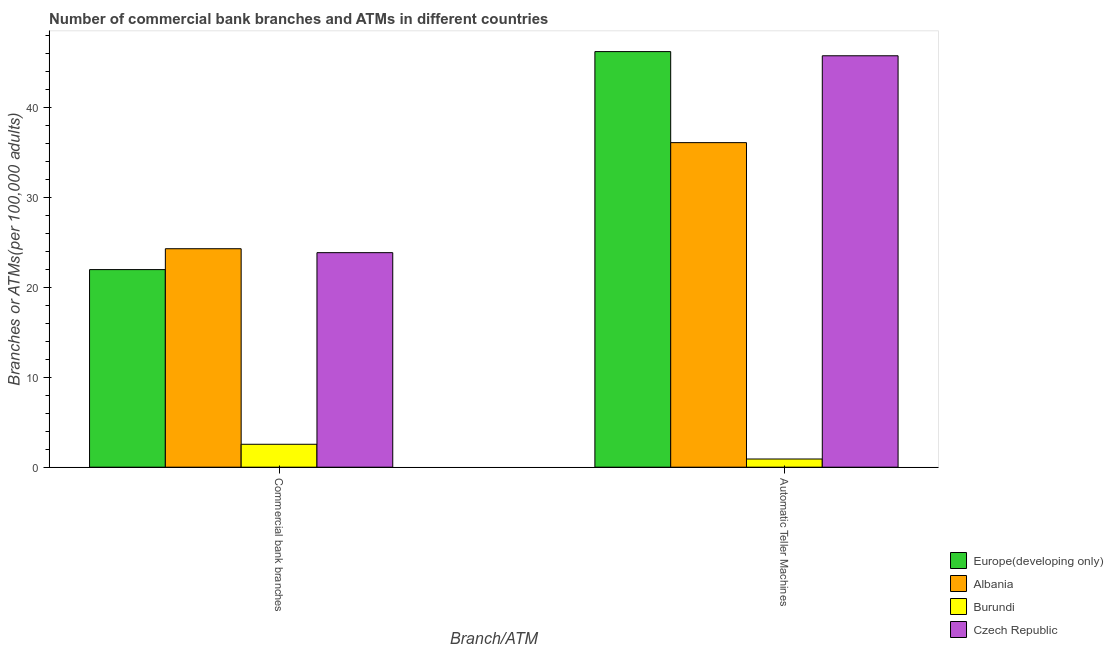How many groups of bars are there?
Your answer should be very brief. 2. Are the number of bars per tick equal to the number of legend labels?
Your answer should be very brief. Yes. How many bars are there on the 2nd tick from the right?
Offer a terse response. 4. What is the label of the 2nd group of bars from the left?
Give a very brief answer. Automatic Teller Machines. What is the number of atms in Albania?
Provide a short and direct response. 36.07. Across all countries, what is the maximum number of commercal bank branches?
Your answer should be very brief. 24.28. Across all countries, what is the minimum number of atms?
Your response must be concise. 0.91. In which country was the number of commercal bank branches maximum?
Your answer should be compact. Albania. In which country was the number of commercal bank branches minimum?
Give a very brief answer. Burundi. What is the total number of commercal bank branches in the graph?
Your answer should be very brief. 72.62. What is the difference between the number of atms in Czech Republic and that in Albania?
Your answer should be very brief. 9.65. What is the difference between the number of commercal bank branches in Burundi and the number of atms in Albania?
Offer a terse response. -33.52. What is the average number of commercal bank branches per country?
Your response must be concise. 18.16. What is the difference between the number of commercal bank branches and number of atms in Europe(developing only)?
Your response must be concise. -24.22. What is the ratio of the number of commercal bank branches in Czech Republic to that in Burundi?
Offer a very short reply. 9.36. In how many countries, is the number of atms greater than the average number of atms taken over all countries?
Offer a terse response. 3. What does the 4th bar from the left in Automatic Teller Machines represents?
Your response must be concise. Czech Republic. What does the 2nd bar from the right in Commercial bank branches represents?
Offer a very short reply. Burundi. How many bars are there?
Your response must be concise. 8. How many countries are there in the graph?
Provide a succinct answer. 4. Are the values on the major ticks of Y-axis written in scientific E-notation?
Provide a succinct answer. No. Does the graph contain any zero values?
Ensure brevity in your answer.  No. Does the graph contain grids?
Give a very brief answer. No. How many legend labels are there?
Make the answer very short. 4. How are the legend labels stacked?
Provide a short and direct response. Vertical. What is the title of the graph?
Your answer should be compact. Number of commercial bank branches and ATMs in different countries. Does "Armenia" appear as one of the legend labels in the graph?
Give a very brief answer. No. What is the label or title of the X-axis?
Keep it short and to the point. Branch/ATM. What is the label or title of the Y-axis?
Make the answer very short. Branches or ATMs(per 100,0 adults). What is the Branches or ATMs(per 100,000 adults) in Europe(developing only) in Commercial bank branches?
Offer a terse response. 21.96. What is the Branches or ATMs(per 100,000 adults) in Albania in Commercial bank branches?
Your response must be concise. 24.28. What is the Branches or ATMs(per 100,000 adults) of Burundi in Commercial bank branches?
Ensure brevity in your answer.  2.55. What is the Branches or ATMs(per 100,000 adults) of Czech Republic in Commercial bank branches?
Provide a succinct answer. 23.84. What is the Branches or ATMs(per 100,000 adults) of Europe(developing only) in Automatic Teller Machines?
Make the answer very short. 46.18. What is the Branches or ATMs(per 100,000 adults) in Albania in Automatic Teller Machines?
Provide a succinct answer. 36.07. What is the Branches or ATMs(per 100,000 adults) of Burundi in Automatic Teller Machines?
Offer a terse response. 0.91. What is the Branches or ATMs(per 100,000 adults) of Czech Republic in Automatic Teller Machines?
Your response must be concise. 45.72. Across all Branch/ATM, what is the maximum Branches or ATMs(per 100,000 adults) in Europe(developing only)?
Provide a succinct answer. 46.18. Across all Branch/ATM, what is the maximum Branches or ATMs(per 100,000 adults) in Albania?
Offer a very short reply. 36.07. Across all Branch/ATM, what is the maximum Branches or ATMs(per 100,000 adults) of Burundi?
Provide a succinct answer. 2.55. Across all Branch/ATM, what is the maximum Branches or ATMs(per 100,000 adults) in Czech Republic?
Offer a terse response. 45.72. Across all Branch/ATM, what is the minimum Branches or ATMs(per 100,000 adults) of Europe(developing only)?
Give a very brief answer. 21.96. Across all Branch/ATM, what is the minimum Branches or ATMs(per 100,000 adults) in Albania?
Your answer should be compact. 24.28. Across all Branch/ATM, what is the minimum Branches or ATMs(per 100,000 adults) in Burundi?
Ensure brevity in your answer.  0.91. Across all Branch/ATM, what is the minimum Branches or ATMs(per 100,000 adults) in Czech Republic?
Keep it short and to the point. 23.84. What is the total Branches or ATMs(per 100,000 adults) in Europe(developing only) in the graph?
Keep it short and to the point. 68.14. What is the total Branches or ATMs(per 100,000 adults) of Albania in the graph?
Ensure brevity in your answer.  60.35. What is the total Branches or ATMs(per 100,000 adults) of Burundi in the graph?
Your answer should be very brief. 3.46. What is the total Branches or ATMs(per 100,000 adults) of Czech Republic in the graph?
Give a very brief answer. 69.56. What is the difference between the Branches or ATMs(per 100,000 adults) in Europe(developing only) in Commercial bank branches and that in Automatic Teller Machines?
Ensure brevity in your answer.  -24.22. What is the difference between the Branches or ATMs(per 100,000 adults) of Albania in Commercial bank branches and that in Automatic Teller Machines?
Make the answer very short. -11.79. What is the difference between the Branches or ATMs(per 100,000 adults) in Burundi in Commercial bank branches and that in Automatic Teller Machines?
Your answer should be compact. 1.64. What is the difference between the Branches or ATMs(per 100,000 adults) of Czech Republic in Commercial bank branches and that in Automatic Teller Machines?
Your answer should be very brief. -21.88. What is the difference between the Branches or ATMs(per 100,000 adults) in Europe(developing only) in Commercial bank branches and the Branches or ATMs(per 100,000 adults) in Albania in Automatic Teller Machines?
Your answer should be very brief. -14.11. What is the difference between the Branches or ATMs(per 100,000 adults) in Europe(developing only) in Commercial bank branches and the Branches or ATMs(per 100,000 adults) in Burundi in Automatic Teller Machines?
Ensure brevity in your answer.  21.05. What is the difference between the Branches or ATMs(per 100,000 adults) in Europe(developing only) in Commercial bank branches and the Branches or ATMs(per 100,000 adults) in Czech Republic in Automatic Teller Machines?
Make the answer very short. -23.76. What is the difference between the Branches or ATMs(per 100,000 adults) in Albania in Commercial bank branches and the Branches or ATMs(per 100,000 adults) in Burundi in Automatic Teller Machines?
Ensure brevity in your answer.  23.37. What is the difference between the Branches or ATMs(per 100,000 adults) in Albania in Commercial bank branches and the Branches or ATMs(per 100,000 adults) in Czech Republic in Automatic Teller Machines?
Provide a short and direct response. -21.44. What is the difference between the Branches or ATMs(per 100,000 adults) in Burundi in Commercial bank branches and the Branches or ATMs(per 100,000 adults) in Czech Republic in Automatic Teller Machines?
Your answer should be compact. -43.17. What is the average Branches or ATMs(per 100,000 adults) of Europe(developing only) per Branch/ATM?
Your answer should be very brief. 34.07. What is the average Branches or ATMs(per 100,000 adults) in Albania per Branch/ATM?
Provide a short and direct response. 30.17. What is the average Branches or ATMs(per 100,000 adults) of Burundi per Branch/ATM?
Make the answer very short. 1.73. What is the average Branches or ATMs(per 100,000 adults) of Czech Republic per Branch/ATM?
Keep it short and to the point. 34.78. What is the difference between the Branches or ATMs(per 100,000 adults) in Europe(developing only) and Branches or ATMs(per 100,000 adults) in Albania in Commercial bank branches?
Provide a short and direct response. -2.32. What is the difference between the Branches or ATMs(per 100,000 adults) in Europe(developing only) and Branches or ATMs(per 100,000 adults) in Burundi in Commercial bank branches?
Offer a terse response. 19.41. What is the difference between the Branches or ATMs(per 100,000 adults) of Europe(developing only) and Branches or ATMs(per 100,000 adults) of Czech Republic in Commercial bank branches?
Make the answer very short. -1.88. What is the difference between the Branches or ATMs(per 100,000 adults) in Albania and Branches or ATMs(per 100,000 adults) in Burundi in Commercial bank branches?
Offer a very short reply. 21.73. What is the difference between the Branches or ATMs(per 100,000 adults) in Albania and Branches or ATMs(per 100,000 adults) in Czech Republic in Commercial bank branches?
Offer a terse response. 0.44. What is the difference between the Branches or ATMs(per 100,000 adults) of Burundi and Branches or ATMs(per 100,000 adults) of Czech Republic in Commercial bank branches?
Your response must be concise. -21.29. What is the difference between the Branches or ATMs(per 100,000 adults) in Europe(developing only) and Branches or ATMs(per 100,000 adults) in Albania in Automatic Teller Machines?
Give a very brief answer. 10.12. What is the difference between the Branches or ATMs(per 100,000 adults) in Europe(developing only) and Branches or ATMs(per 100,000 adults) in Burundi in Automatic Teller Machines?
Keep it short and to the point. 45.27. What is the difference between the Branches or ATMs(per 100,000 adults) of Europe(developing only) and Branches or ATMs(per 100,000 adults) of Czech Republic in Automatic Teller Machines?
Your answer should be compact. 0.46. What is the difference between the Branches or ATMs(per 100,000 adults) of Albania and Branches or ATMs(per 100,000 adults) of Burundi in Automatic Teller Machines?
Make the answer very short. 35.16. What is the difference between the Branches or ATMs(per 100,000 adults) in Albania and Branches or ATMs(per 100,000 adults) in Czech Republic in Automatic Teller Machines?
Provide a succinct answer. -9.65. What is the difference between the Branches or ATMs(per 100,000 adults) of Burundi and Branches or ATMs(per 100,000 adults) of Czech Republic in Automatic Teller Machines?
Ensure brevity in your answer.  -44.81. What is the ratio of the Branches or ATMs(per 100,000 adults) in Europe(developing only) in Commercial bank branches to that in Automatic Teller Machines?
Keep it short and to the point. 0.48. What is the ratio of the Branches or ATMs(per 100,000 adults) in Albania in Commercial bank branches to that in Automatic Teller Machines?
Your response must be concise. 0.67. What is the ratio of the Branches or ATMs(per 100,000 adults) in Burundi in Commercial bank branches to that in Automatic Teller Machines?
Make the answer very short. 2.8. What is the ratio of the Branches or ATMs(per 100,000 adults) in Czech Republic in Commercial bank branches to that in Automatic Teller Machines?
Offer a very short reply. 0.52. What is the difference between the highest and the second highest Branches or ATMs(per 100,000 adults) in Europe(developing only)?
Make the answer very short. 24.22. What is the difference between the highest and the second highest Branches or ATMs(per 100,000 adults) of Albania?
Your response must be concise. 11.79. What is the difference between the highest and the second highest Branches or ATMs(per 100,000 adults) of Burundi?
Offer a terse response. 1.64. What is the difference between the highest and the second highest Branches or ATMs(per 100,000 adults) of Czech Republic?
Offer a very short reply. 21.88. What is the difference between the highest and the lowest Branches or ATMs(per 100,000 adults) of Europe(developing only)?
Give a very brief answer. 24.22. What is the difference between the highest and the lowest Branches or ATMs(per 100,000 adults) in Albania?
Your answer should be compact. 11.79. What is the difference between the highest and the lowest Branches or ATMs(per 100,000 adults) in Burundi?
Ensure brevity in your answer.  1.64. What is the difference between the highest and the lowest Branches or ATMs(per 100,000 adults) of Czech Republic?
Your answer should be very brief. 21.88. 